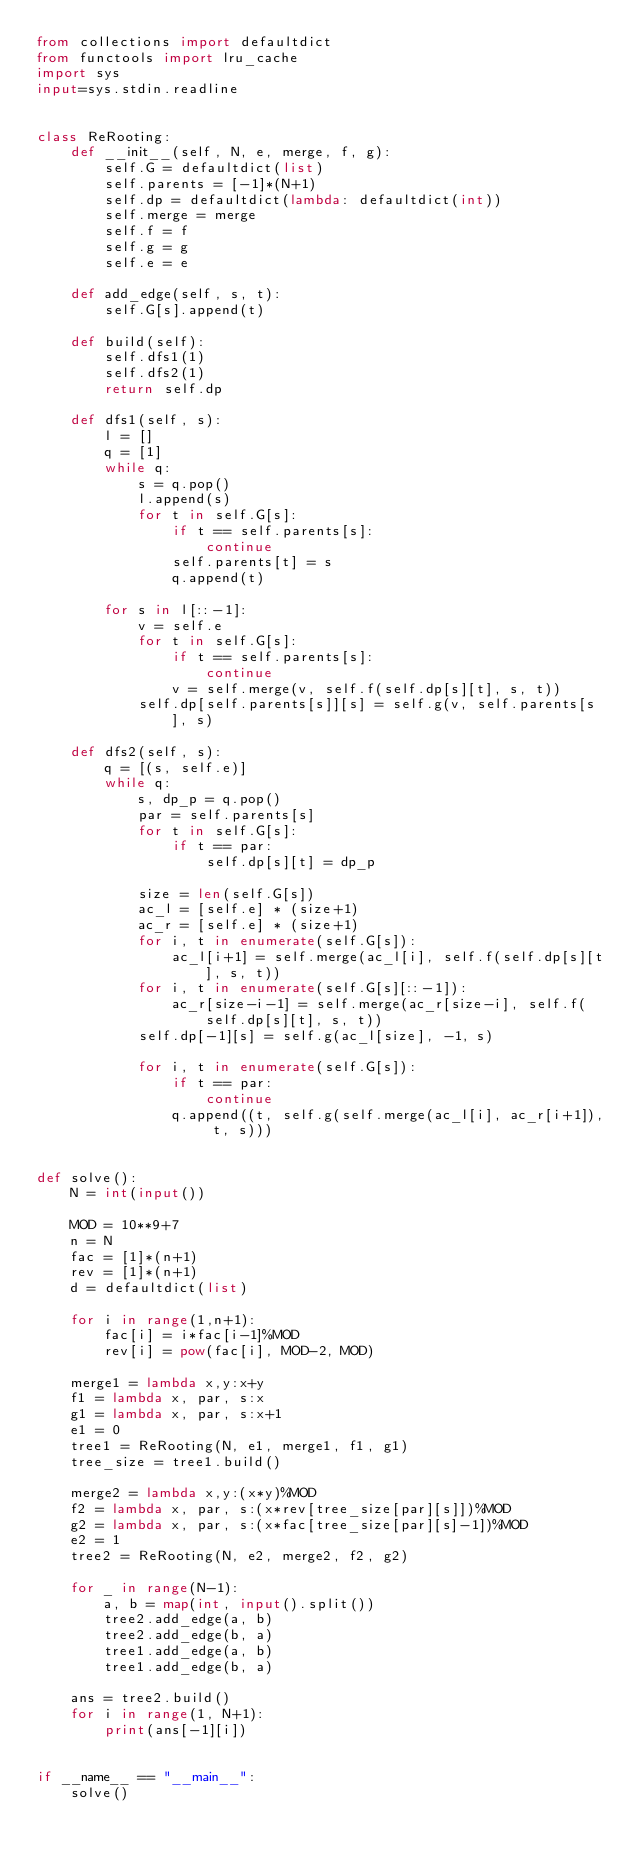Convert code to text. <code><loc_0><loc_0><loc_500><loc_500><_Python_>from collections import defaultdict
from functools import lru_cache
import sys
input=sys.stdin.readline


class ReRooting:
    def __init__(self, N, e, merge, f, g):
        self.G = defaultdict(list)
        self.parents = [-1]*(N+1)
        self.dp = defaultdict(lambda: defaultdict(int))
        self.merge = merge
        self.f = f
        self.g = g
        self.e = e

    def add_edge(self, s, t):
        self.G[s].append(t)

    def build(self):
        self.dfs1(1)
        self.dfs2(1)
        return self.dp

    def dfs1(self, s):
        l = []
        q = [1]
        while q:
            s = q.pop()
            l.append(s)
            for t in self.G[s]:
                if t == self.parents[s]:
                    continue
                self.parents[t] = s
                q.append(t)

        for s in l[::-1]:
            v = self.e
            for t in self.G[s]:
                if t == self.parents[s]:
                    continue
                v = self.merge(v, self.f(self.dp[s][t], s, t))
            self.dp[self.parents[s]][s] = self.g(v, self.parents[s], s)

    def dfs2(self, s):
        q = [(s, self.e)]
        while q:
            s, dp_p = q.pop()
            par = self.parents[s]
            for t in self.G[s]:
                if t == par:
                    self.dp[s][t] = dp_p

            size = len(self.G[s])
            ac_l = [self.e] * (size+1)
            ac_r = [self.e] * (size+1)
            for i, t in enumerate(self.G[s]):
                ac_l[i+1] = self.merge(ac_l[i], self.f(self.dp[s][t], s, t))
            for i, t in enumerate(self.G[s][::-1]):
                ac_r[size-i-1] = self.merge(ac_r[size-i], self.f(self.dp[s][t], s, t))
            self.dp[-1][s] = self.g(ac_l[size], -1, s)

            for i, t in enumerate(self.G[s]):
                if t == par:
                    continue
                q.append((t, self.g(self.merge(ac_l[i], ac_r[i+1]), t, s)))


def solve():
    N = int(input())

    MOD = 10**9+7
    n = N
    fac = [1]*(n+1)
    rev = [1]*(n+1)
    d = defaultdict(list)

    for i in range(1,n+1):
        fac[i] = i*fac[i-1]%MOD
        rev[i] = pow(fac[i], MOD-2, MOD)

    merge1 = lambda x,y:x+y
    f1 = lambda x, par, s:x
    g1 = lambda x, par, s:x+1
    e1 = 0
    tree1 = ReRooting(N, e1, merge1, f1, g1)
    tree_size = tree1.build()

    merge2 = lambda x,y:(x*y)%MOD
    f2 = lambda x, par, s:(x*rev[tree_size[par][s]])%MOD
    g2 = lambda x, par, s:(x*fac[tree_size[par][s]-1])%MOD
    e2 = 1
    tree2 = ReRooting(N, e2, merge2, f2, g2)

    for _ in range(N-1):
        a, b = map(int, input().split())
        tree2.add_edge(a, b)
        tree2.add_edge(b, a)
        tree1.add_edge(a, b)
        tree1.add_edge(b, a)

    ans = tree2.build()
    for i in range(1, N+1):
        print(ans[-1][i])


if __name__ == "__main__":
    solve()
</code> 